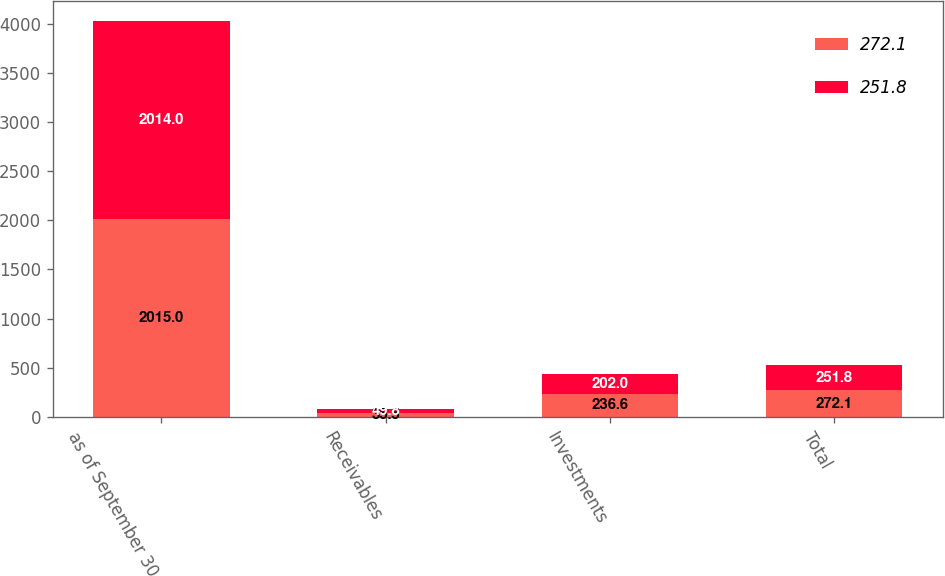Convert chart to OTSL. <chart><loc_0><loc_0><loc_500><loc_500><stacked_bar_chart><ecel><fcel>as of September 30<fcel>Receivables<fcel>Investments<fcel>Total<nl><fcel>272.1<fcel>2015<fcel>35.5<fcel>236.6<fcel>272.1<nl><fcel>251.8<fcel>2014<fcel>49.8<fcel>202<fcel>251.8<nl></chart> 